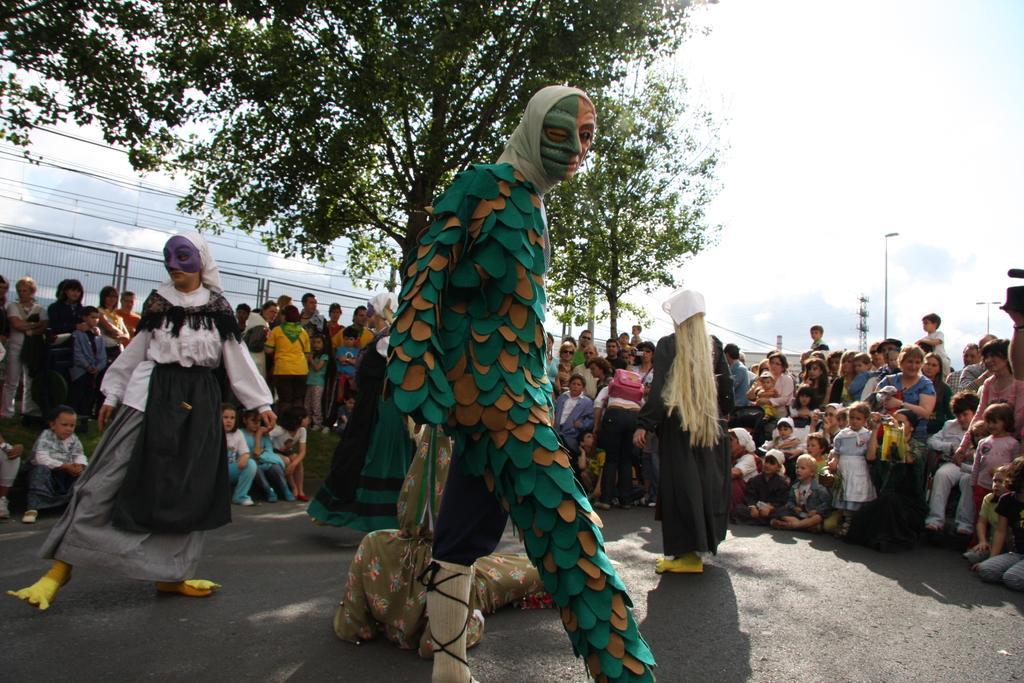Please provide a concise description of this image. In front of the image there is a person holding some object. Behind him there are three people wearing a costume. In the background of the image there are a few people sitting and there are a few people standing. There is a metal fence, tower, light poles, trees and a building. At the top of the image there are clouds in the sky. 